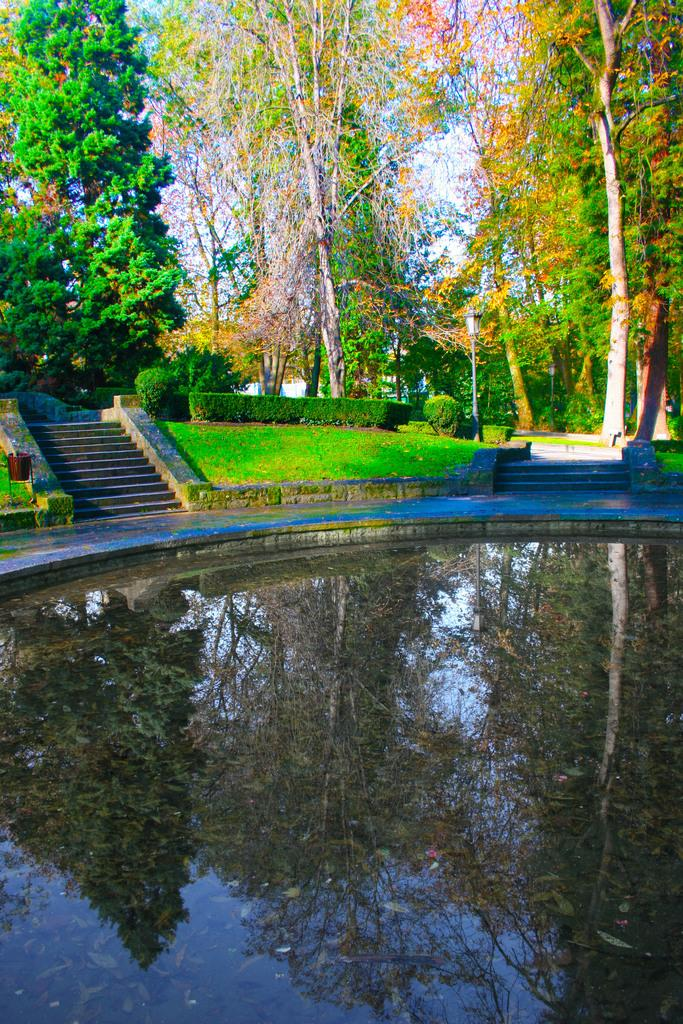What is the primary element present in the image? There is water in the image. What architectural feature can be seen in the background of the image? There are stairs visible in the background of the image. What type of vegetation is present in the image? There is grass and trees in the image, both described as green. What part of the natural environment is visible in the image? The sky is visible in the image, described as white. What type of insurance policy is being discussed in the image? There is no mention of insurance or any discussion in the image; it primarily features water, stairs, grass, trees, and the sky. 